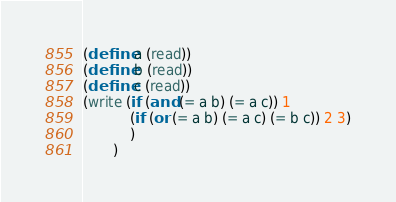<code> <loc_0><loc_0><loc_500><loc_500><_Scheme_>(define a (read))
(define b (read))
(define c (read))
(write (if (and (= a b) (= a c)) 1
           (if (or (= a b) (= a c) (= b c)) 2 3)
           )
       )
</code> 